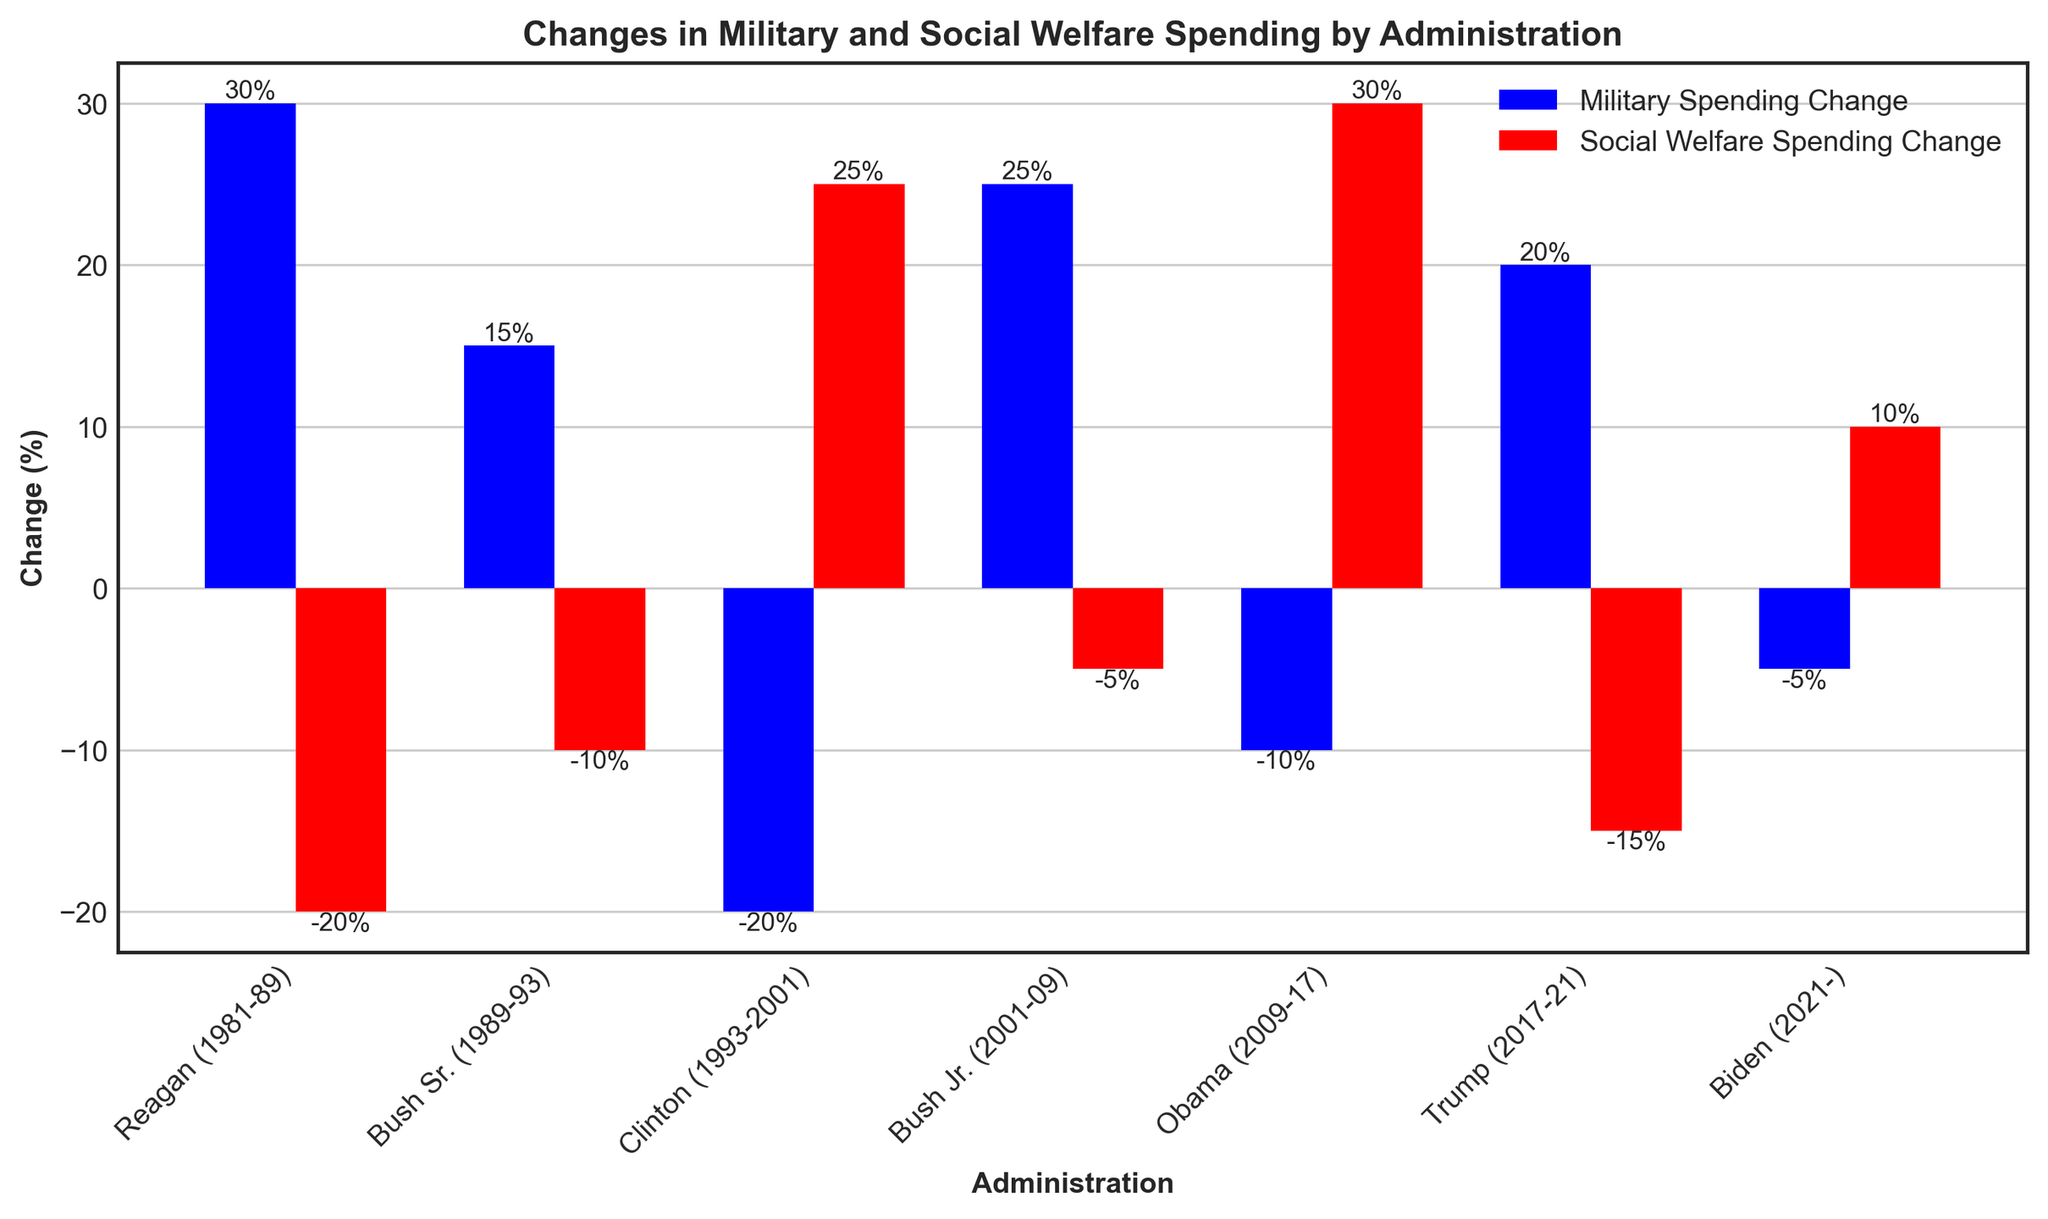Which administration had the highest increase in military spending? To find the administration with the highest increase, look at the blue bars in the chart and identify the tallest one. The tallest blue bar represents the Reagan administration.
Answer: Reagan During which administration did social welfare spending decrease the most? To find the administration with the largest decrease in social welfare spending, look at the red bars and identify the lowest one. The lowest red bar is seen in the Reagan administration.
Answer: Reagan Compare the changes in military and social welfare spending during Trump's administration. Which had a higher change and by how much? For Trump's administration, the change in military spending is +20%, and the change in social welfare spending is -15%. The difference in change is 20 - (-15) = 35%.
Answer: Military spending by 35% What is the net change (sum of increases and decreases) in military spending under Clinton and Obama administrations? For Clinton: -20%; for Obama: -10%. The net change is -20 + (-10) = -30%.
Answer: -30% Which administrations saw a decrease in military spending? Identify the administrations with negative blue bars. Clinton, Obama, and Biden administrations all show a decrease.
Answer: Clinton, Obama, Biden For the Bush Jr. administration, how did the change in social welfare spending compare to the change in military spending? Bush Jr. had an increase of 25% in military spending and a decrease of 5% in social welfare spending, making the change in military spending higher.
Answer: Military spending higher by 30% Which administrations saw an increase in social welfare spending? Identify the administrations with positive red bars. Clinton, Obama, and Biden show increases in social welfare spending.
Answer: Clinton, Obama, Biden What is the average change in social welfare spending across all administrations? Sum the changes in social welfare spending and divide by the number of administrations. The sum is -20 - 10 + 25 - 5 + 30 - 15 + 10 = 15. There are 7 administrations, so the average is 15/7 ≈ 2.14%.
Answer: 2.14% By how much did the change in military spending during the Reagan administration exceed the change in military spending during the Clinton administration? Reagan had a 30% increase, and Clinton had a 20% decrease. The difference is 30 - (-20) = 50%.
Answer: 50% What is the combined change in social welfare spending during the Bush Sr. and Trump administrations? Bush Sr. had a -10% change, and Trump had a -15% change. The combined change is -10 + (-15) = -25%.
Answer: -25% 